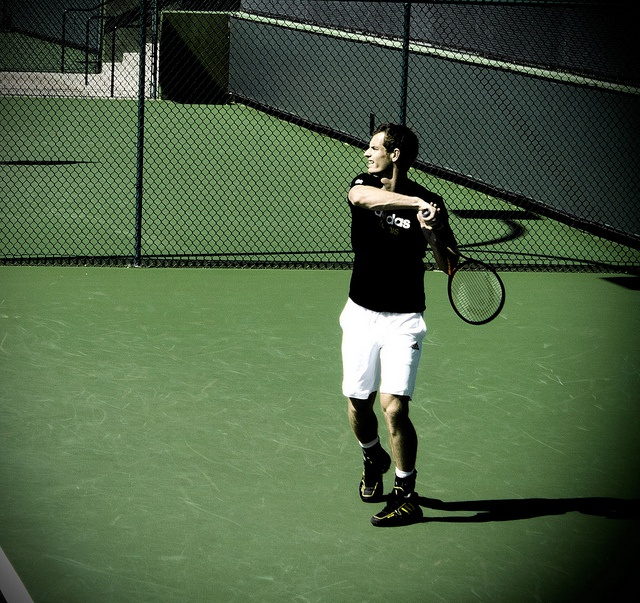Describe the objects in this image and their specific colors. I can see people in black, white, green, and gray tones and tennis racket in black, green, and darkgreen tones in this image. 